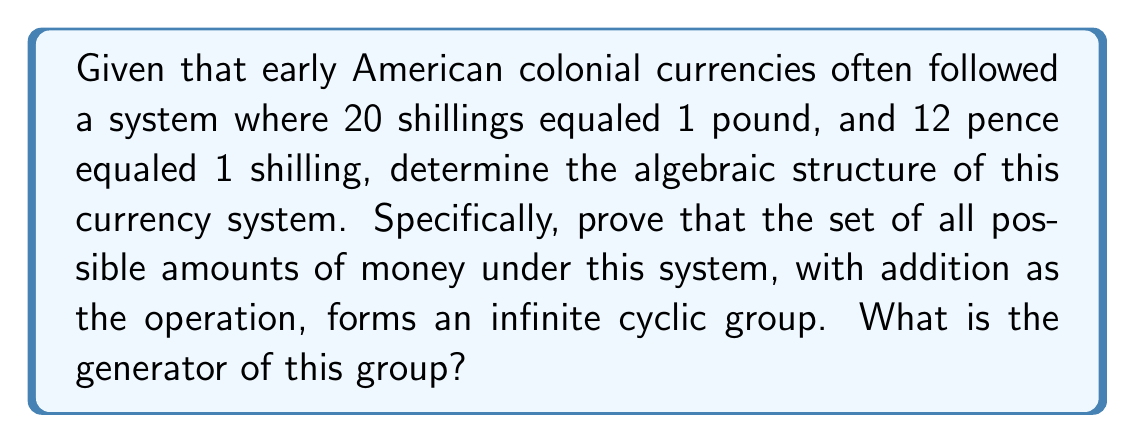What is the answer to this math problem? To prove that the early American colonial currency system forms an infinite cyclic group under addition, we need to show that:

1. The set is closed under addition.
2. Addition is associative.
3. There exists an identity element.
4. Every element has an inverse.
5. There exists a generator that can produce all elements of the group.

Step 1: Closure
Any amount of money can be expressed as a combination of pounds, shillings, and pence. Let's denote the smallest unit (1 pence) as our base unit. Then any amount can be represented as an integer multiple of this base unit. Therefore, the set is closed under addition.

Step 2: Associativity
Addition of integers is associative, so this property holds.

Step 3: Identity Element
The identity element is 0 pence (or £0 0s 0d), as adding this to any amount leaves it unchanged.

Step 4: Inverse
For any amount of money, we can find its inverse by negating it. For example, the inverse of £1 5s 6d is -£1 -5s -6d.

Step 5: Generator
To find the generator, we need to identify the smallest positive amount that can generate all other amounts through repeated addition. This is 1 pence.

Proof:
Let $g = 1$ pence. Then:
$$1 \cdot g = 1d$$
$$12 \cdot g = 1s$$
$$240 \cdot g = £1$$

Any amount of money can be expressed as an integer combination of these:

$$a \cdot £1 + b \cdot 1s + c \cdot 1d = (240a + 12b + c) \cdot g$$

where $a$, $b$, and $c$ are integers, and $0 \leq b < 20$, $0 \leq c < 12$.

Therefore, 1 pence (g) is the generator of the group, and the group is isomorphic to the additive group of integers $(\mathbb{Z}, +)$, which is an infinite cyclic group.
Answer: $1$ pence 